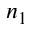<formula> <loc_0><loc_0><loc_500><loc_500>n _ { 1 }</formula> 